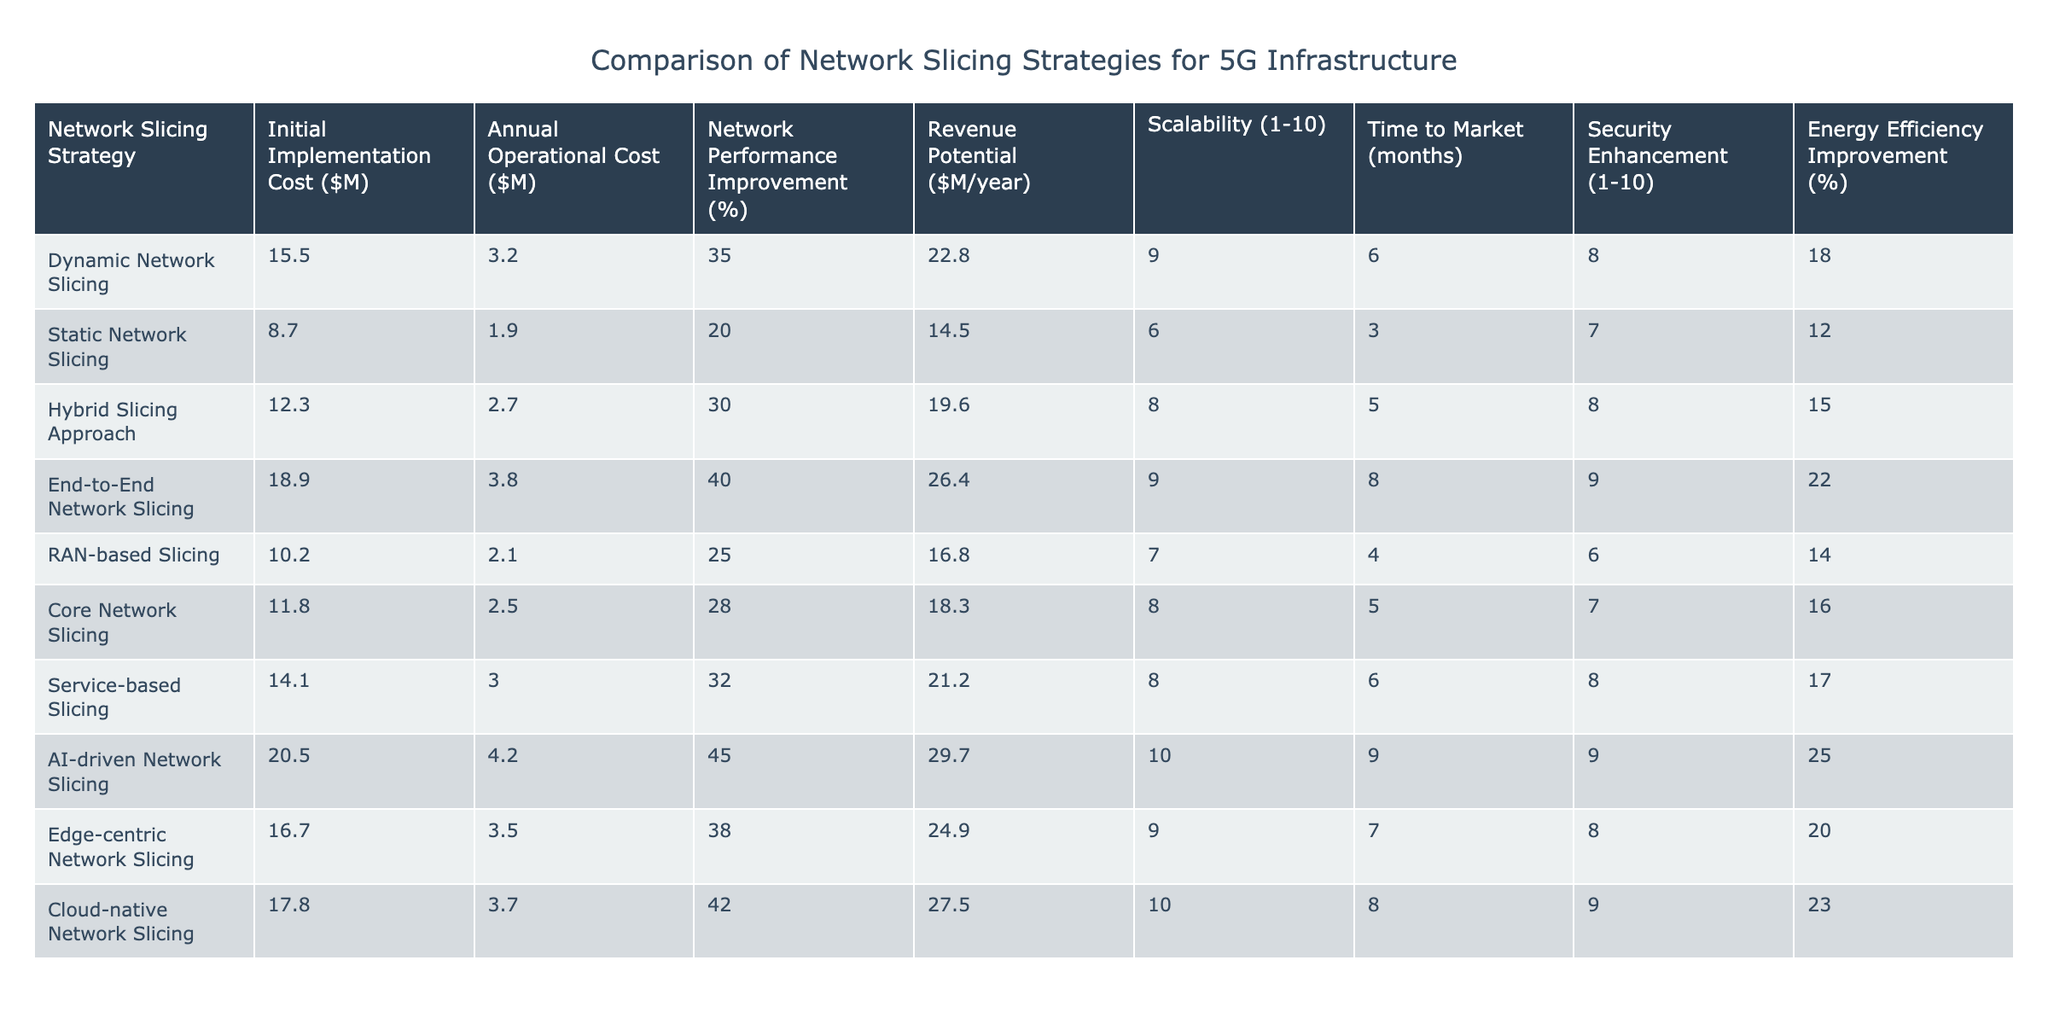What is the initial implementation cost of the AI-driven network slicing strategy? According to the table, the initial implementation cost for the AI-driven network slicing strategy is listed as $20.5 million.
Answer: 20.5 million Which network slicing strategy has the lowest annual operational cost? The table shows that static network slicing has the lowest annual operational cost at $1.9 million.
Answer: 1.9 million What is the average network performance improvement across all strategies? To find the average, add all the network performance improvements: (35 + 20 + 30 + 40 + 25 + 28 + 32 + 45 + 38 + 42) =  335. There are 10 strategies, so the average is 335 / 10 = 33.5%.
Answer: 33.5% Is the revenue potential higher for static network slicing compared to RAN-based slicing? From the table, static network slicing shows a revenue potential of $14.5 million while RAN-based slicing shows $16.8 million. Thus, the statement is false.
Answer: No Which slicing strategy provides the highest scalability rating? The table indicates that the AI-driven network slicing strategy has the highest scalability rating of 10.
Answer: 10 What is the difference in annual operational costs between the end-to-end network slicing and the cloud-native network slicing strategies? The annual operational cost for end-to-end network slicing is $3.8 million, while for cloud-native it is $3.7 million. The difference is $3.8 million - $3.7 million = $0.1 million.
Answer: 0.1 million Which network slicing strategy has the highest combination of revenue potential and network performance improvement? First, we add the revenue potential to network performance improvement for each strategy. For AI-driven slicing: 29.7 + 45 = 74.7 million. For end-to-end slicing: 26.4 + 40 = 66.4 million. For dynamic slicing: 22.8 + 35 = 57.8 million. The AI-driven network slicing strategy has the highest total of 74.7 million.
Answer: AI-driven network slicing Does the hybrid slicing approach have a higher energy efficiency improvement percentage than static network slicing? The hybrid slicing approach has an energy efficiency improvement of 15%, while the static network slicing shows a 12% improvement. The statement is true.
Answer: Yes What is the total initial implementation cost of the top three strategies with the highest network performance improvement? The top three strategies by network performance improvement are AI-driven (20.5 M), end-to-end (18.9 M), and dynamic (15.5 M) slicing. Adding these gives 20.5 + 18.9 + 15.5 = 54.9 million.
Answer: 54.9 million 